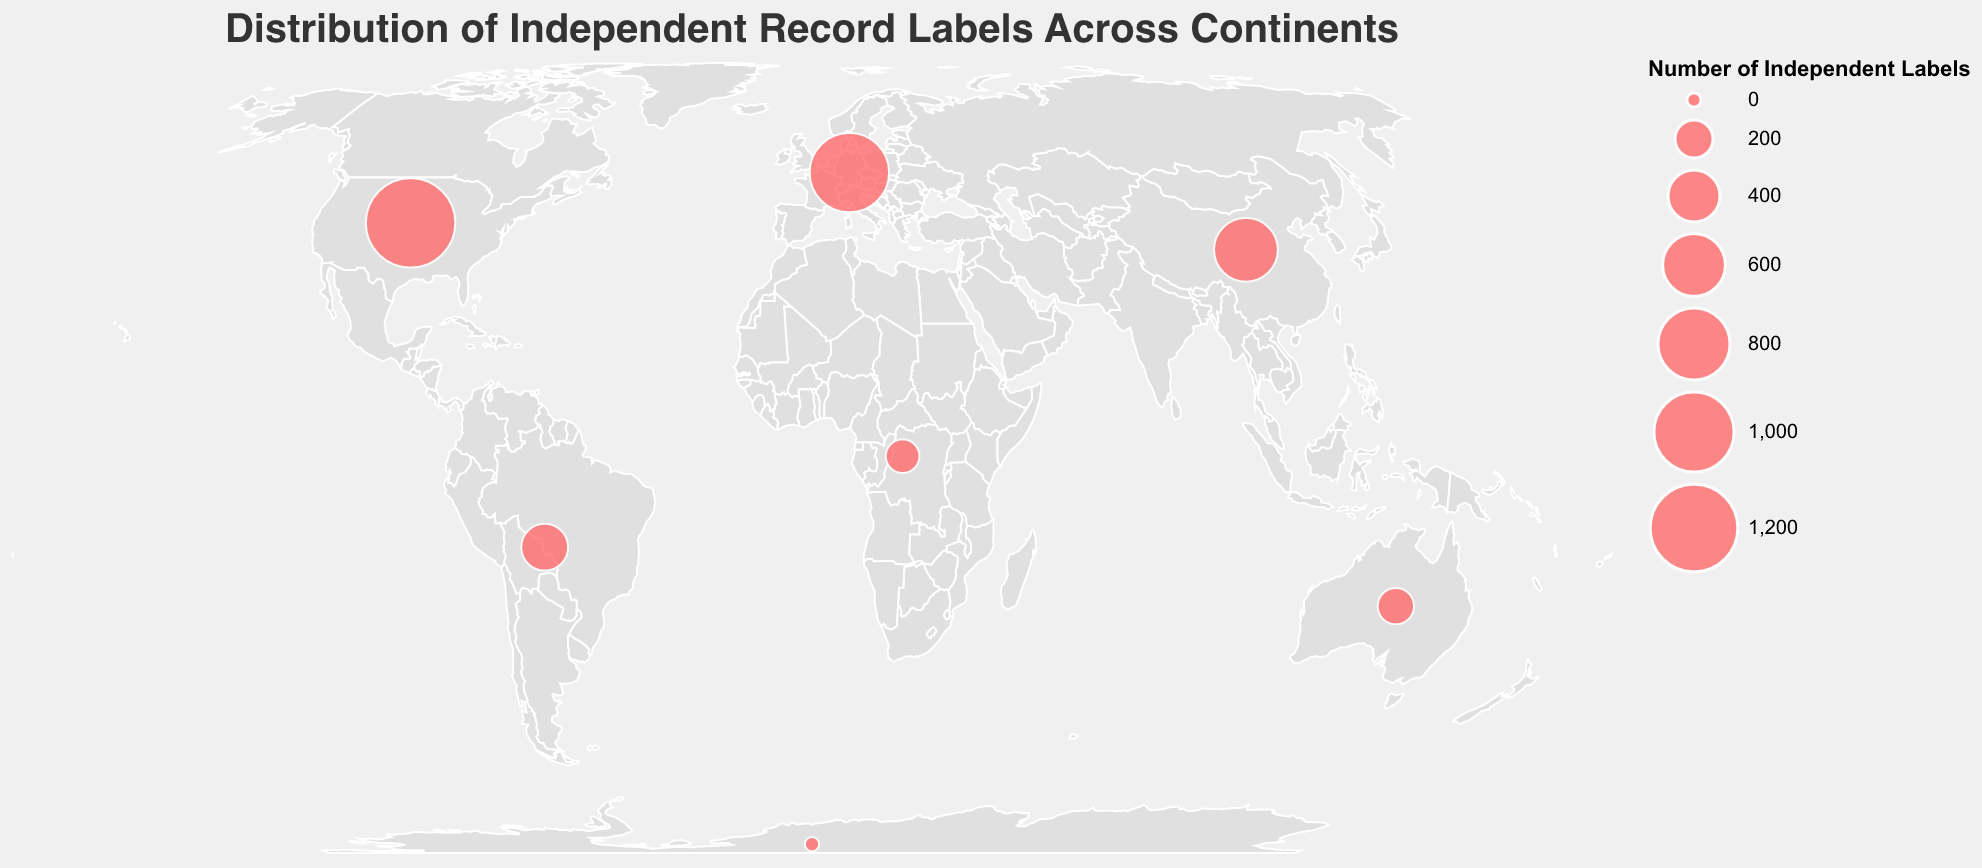Which continent has the highest number of independent record labels? The figure shows circles representing the number of independent record labels. The largest circle appears over North America.
Answer: North America What is the title of the figure? The title is prominently displayed at the top of the figure, providing a clear description of the data.
Answer: Distribution of Independent Record Labels Across Continents Which notable label for MILOUX fans is based in Europe? The tooltip information on the figure shows the label associated with each continent. The notable label for Europe is listed as Ninja Tune.
Answer: Ninja Tune How many continents have more than 500 independent record labels? By evaluating the size of circles and using the tooltip, we determine that North America, Europe, and Asia have more than 500 independent record labels. That makes three continents.
Answer: 3 Which continent has the least number of independent record labels? As displayed on the figure, Antarctica has the smallest circle, representing the least number of independent record labels.
Answer: Antarctica What is the combined number of independent record labels in Africa and Oceania? Checking the data associated with the circles for Africa and Oceania, we see 150 for Africa and 180 for Oceania. Adding these gives 150 + 180 = 330.
Answer: 330 Identify the continent with the label "Flying Nun Records" associated with it. The tooltip linked to the circle positioned over Oceania reveals the notable label as Flying Nun Records.
Answer: Oceania Which continent(s) have fewer independent record labels than South America? By comparing circle sizes, Africa (150), Oceania (180), and Antarctica (1) all have fewer labels than South America (320).
Answer: Africa, Oceania, Antarctica What specific visual elements differentiate notable labels for MILOUX fans on the map? Notable labels are displayed as part of the tooltip information that appears when hovering over each circle on the map.
Answer: Tooltip What is the average number of independent record labels in North America and Europe? Summing up the numbers for North America (1250) and Europe (980) we get 1250 + 980 = 2230, and dividing by 2 gives 2230/2 = 1115.
Answer: 1115 